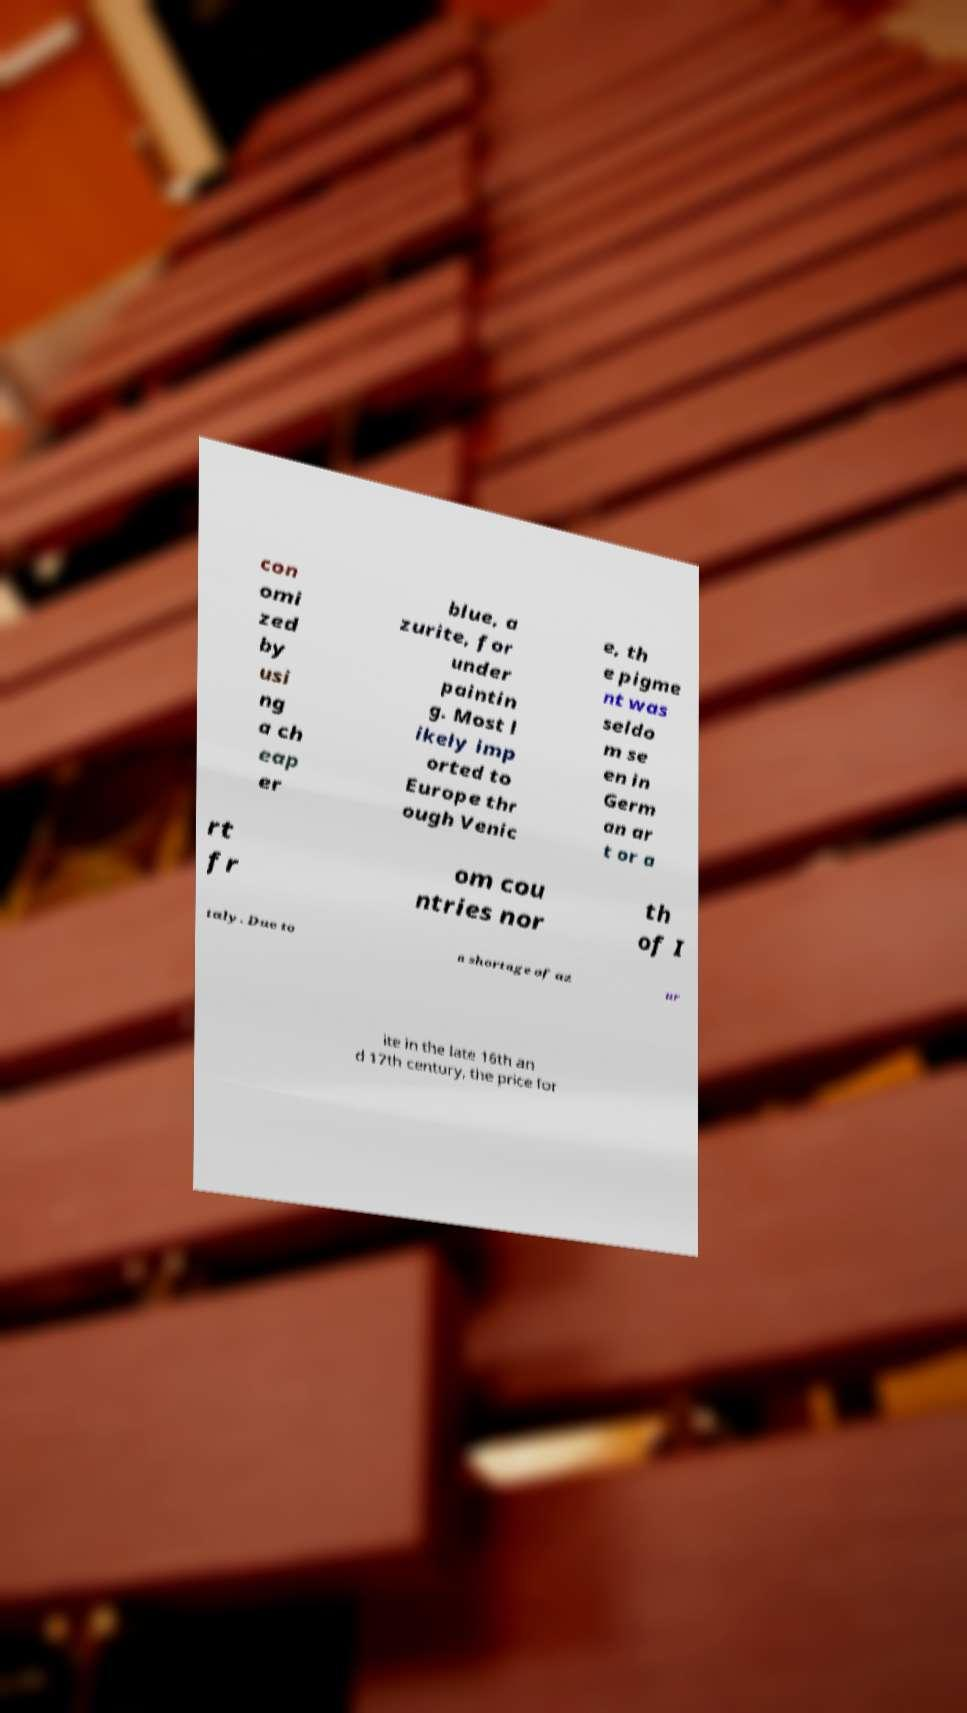Please read and relay the text visible in this image. What does it say? con omi zed by usi ng a ch eap er blue, a zurite, for under paintin g. Most l ikely imp orted to Europe thr ough Venic e, th e pigme nt was seldo m se en in Germ an ar t or a rt fr om cou ntries nor th of I taly. Due to a shortage of az ur ite in the late 16th an d 17th century, the price for 